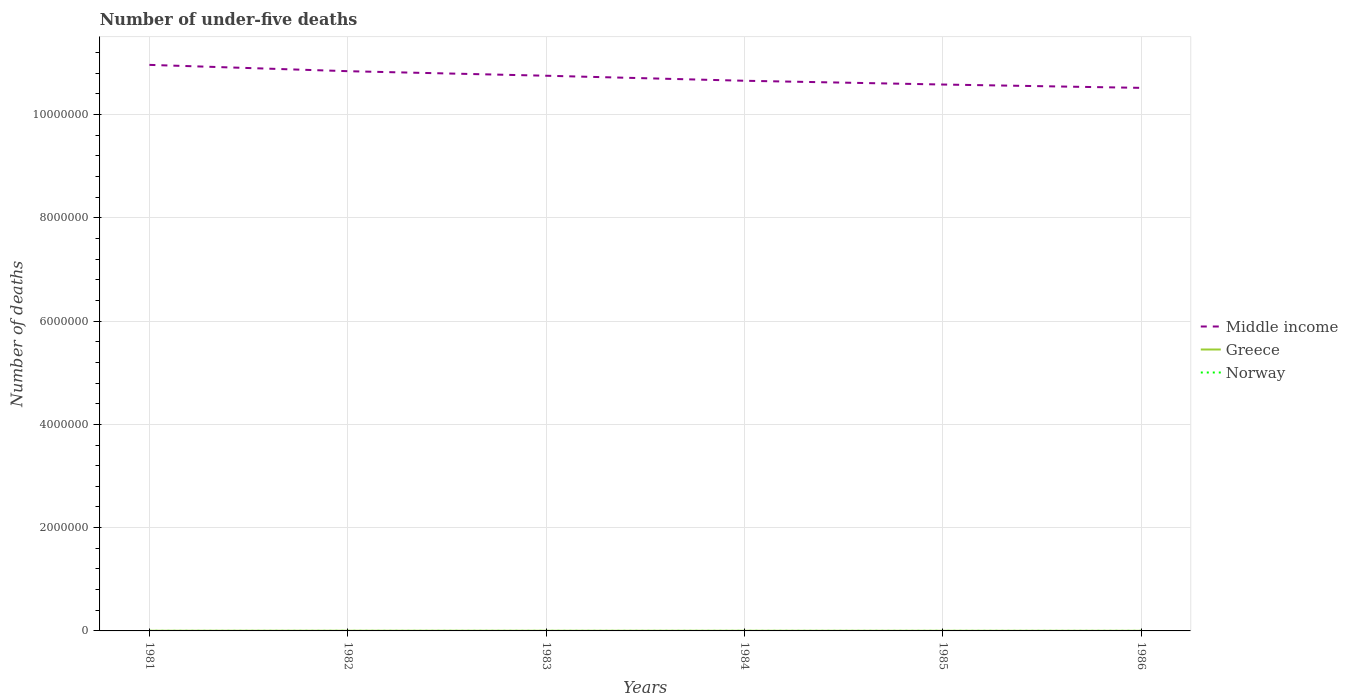How many different coloured lines are there?
Make the answer very short. 3. Across all years, what is the maximum number of under-five deaths in Greece?
Your answer should be compact. 2088. What is the total number of under-five deaths in Norway in the graph?
Your response must be concise. -61. What is the difference between the highest and the second highest number of under-five deaths in Norway?
Your response must be concise. 88. How many lines are there?
Provide a succinct answer. 3. What is the difference between two consecutive major ticks on the Y-axis?
Your answer should be compact. 2.00e+06. Are the values on the major ticks of Y-axis written in scientific E-notation?
Provide a short and direct response. No. Does the graph contain grids?
Provide a short and direct response. Yes. Where does the legend appear in the graph?
Offer a very short reply. Center right. How many legend labels are there?
Keep it short and to the point. 3. How are the legend labels stacked?
Make the answer very short. Vertical. What is the title of the graph?
Offer a terse response. Number of under-five deaths. Does "Iran" appear as one of the legend labels in the graph?
Provide a short and direct response. No. What is the label or title of the Y-axis?
Ensure brevity in your answer.  Number of deaths. What is the Number of deaths in Middle income in 1981?
Offer a terse response. 1.10e+07. What is the Number of deaths of Greece in 1981?
Your response must be concise. 3447. What is the Number of deaths in Norway in 1981?
Provide a short and direct response. 481. What is the Number of deaths in Middle income in 1982?
Your answer should be very brief. 1.08e+07. What is the Number of deaths in Greece in 1982?
Ensure brevity in your answer.  3181. What is the Number of deaths of Norway in 1982?
Provide a short and direct response. 489. What is the Number of deaths of Middle income in 1983?
Make the answer very short. 1.08e+07. What is the Number of deaths in Greece in 1983?
Give a very brief answer. 2898. What is the Number of deaths in Norway in 1983?
Offer a terse response. 508. What is the Number of deaths in Middle income in 1984?
Offer a very short reply. 1.07e+07. What is the Number of deaths in Greece in 1984?
Keep it short and to the point. 2618. What is the Number of deaths in Norway in 1984?
Offer a terse response. 530. What is the Number of deaths of Middle income in 1985?
Give a very brief answer. 1.06e+07. What is the Number of deaths in Greece in 1985?
Your response must be concise. 2340. What is the Number of deaths in Norway in 1985?
Provide a succinct answer. 550. What is the Number of deaths in Middle income in 1986?
Your answer should be very brief. 1.05e+07. What is the Number of deaths in Greece in 1986?
Offer a terse response. 2088. What is the Number of deaths in Norway in 1986?
Make the answer very short. 569. Across all years, what is the maximum Number of deaths of Middle income?
Give a very brief answer. 1.10e+07. Across all years, what is the maximum Number of deaths of Greece?
Your response must be concise. 3447. Across all years, what is the maximum Number of deaths of Norway?
Your response must be concise. 569. Across all years, what is the minimum Number of deaths in Middle income?
Your answer should be very brief. 1.05e+07. Across all years, what is the minimum Number of deaths in Greece?
Give a very brief answer. 2088. Across all years, what is the minimum Number of deaths in Norway?
Your response must be concise. 481. What is the total Number of deaths in Middle income in the graph?
Your answer should be very brief. 6.43e+07. What is the total Number of deaths in Greece in the graph?
Your answer should be compact. 1.66e+04. What is the total Number of deaths in Norway in the graph?
Ensure brevity in your answer.  3127. What is the difference between the Number of deaths of Middle income in 1981 and that in 1982?
Provide a short and direct response. 1.22e+05. What is the difference between the Number of deaths of Greece in 1981 and that in 1982?
Your answer should be compact. 266. What is the difference between the Number of deaths of Norway in 1981 and that in 1982?
Make the answer very short. -8. What is the difference between the Number of deaths in Middle income in 1981 and that in 1983?
Make the answer very short. 2.10e+05. What is the difference between the Number of deaths of Greece in 1981 and that in 1983?
Keep it short and to the point. 549. What is the difference between the Number of deaths of Norway in 1981 and that in 1983?
Your response must be concise. -27. What is the difference between the Number of deaths of Middle income in 1981 and that in 1984?
Provide a succinct answer. 3.08e+05. What is the difference between the Number of deaths of Greece in 1981 and that in 1984?
Offer a terse response. 829. What is the difference between the Number of deaths of Norway in 1981 and that in 1984?
Offer a terse response. -49. What is the difference between the Number of deaths of Middle income in 1981 and that in 1985?
Provide a succinct answer. 3.81e+05. What is the difference between the Number of deaths in Greece in 1981 and that in 1985?
Offer a terse response. 1107. What is the difference between the Number of deaths of Norway in 1981 and that in 1985?
Provide a short and direct response. -69. What is the difference between the Number of deaths of Middle income in 1981 and that in 1986?
Your answer should be very brief. 4.45e+05. What is the difference between the Number of deaths of Greece in 1981 and that in 1986?
Provide a short and direct response. 1359. What is the difference between the Number of deaths in Norway in 1981 and that in 1986?
Offer a terse response. -88. What is the difference between the Number of deaths in Middle income in 1982 and that in 1983?
Keep it short and to the point. 8.81e+04. What is the difference between the Number of deaths of Greece in 1982 and that in 1983?
Ensure brevity in your answer.  283. What is the difference between the Number of deaths of Norway in 1982 and that in 1983?
Your response must be concise. -19. What is the difference between the Number of deaths of Middle income in 1982 and that in 1984?
Ensure brevity in your answer.  1.85e+05. What is the difference between the Number of deaths of Greece in 1982 and that in 1984?
Give a very brief answer. 563. What is the difference between the Number of deaths in Norway in 1982 and that in 1984?
Keep it short and to the point. -41. What is the difference between the Number of deaths in Middle income in 1982 and that in 1985?
Provide a short and direct response. 2.58e+05. What is the difference between the Number of deaths in Greece in 1982 and that in 1985?
Your answer should be compact. 841. What is the difference between the Number of deaths of Norway in 1982 and that in 1985?
Your response must be concise. -61. What is the difference between the Number of deaths of Middle income in 1982 and that in 1986?
Your answer should be compact. 3.23e+05. What is the difference between the Number of deaths of Greece in 1982 and that in 1986?
Provide a short and direct response. 1093. What is the difference between the Number of deaths in Norway in 1982 and that in 1986?
Offer a terse response. -80. What is the difference between the Number of deaths of Middle income in 1983 and that in 1984?
Your response must be concise. 9.72e+04. What is the difference between the Number of deaths in Greece in 1983 and that in 1984?
Offer a very short reply. 280. What is the difference between the Number of deaths in Middle income in 1983 and that in 1985?
Your answer should be very brief. 1.70e+05. What is the difference between the Number of deaths of Greece in 1983 and that in 1985?
Keep it short and to the point. 558. What is the difference between the Number of deaths of Norway in 1983 and that in 1985?
Provide a short and direct response. -42. What is the difference between the Number of deaths of Middle income in 1983 and that in 1986?
Your answer should be very brief. 2.35e+05. What is the difference between the Number of deaths of Greece in 1983 and that in 1986?
Keep it short and to the point. 810. What is the difference between the Number of deaths in Norway in 1983 and that in 1986?
Offer a very short reply. -61. What is the difference between the Number of deaths in Middle income in 1984 and that in 1985?
Give a very brief answer. 7.30e+04. What is the difference between the Number of deaths in Greece in 1984 and that in 1985?
Make the answer very short. 278. What is the difference between the Number of deaths of Norway in 1984 and that in 1985?
Provide a succinct answer. -20. What is the difference between the Number of deaths of Middle income in 1984 and that in 1986?
Provide a short and direct response. 1.38e+05. What is the difference between the Number of deaths in Greece in 1984 and that in 1986?
Your answer should be very brief. 530. What is the difference between the Number of deaths in Norway in 1984 and that in 1986?
Keep it short and to the point. -39. What is the difference between the Number of deaths in Middle income in 1985 and that in 1986?
Ensure brevity in your answer.  6.48e+04. What is the difference between the Number of deaths in Greece in 1985 and that in 1986?
Make the answer very short. 252. What is the difference between the Number of deaths of Middle income in 1981 and the Number of deaths of Greece in 1982?
Keep it short and to the point. 1.10e+07. What is the difference between the Number of deaths in Middle income in 1981 and the Number of deaths in Norway in 1982?
Provide a succinct answer. 1.10e+07. What is the difference between the Number of deaths in Greece in 1981 and the Number of deaths in Norway in 1982?
Your answer should be compact. 2958. What is the difference between the Number of deaths in Middle income in 1981 and the Number of deaths in Greece in 1983?
Your answer should be compact. 1.10e+07. What is the difference between the Number of deaths of Middle income in 1981 and the Number of deaths of Norway in 1983?
Offer a terse response. 1.10e+07. What is the difference between the Number of deaths in Greece in 1981 and the Number of deaths in Norway in 1983?
Provide a succinct answer. 2939. What is the difference between the Number of deaths in Middle income in 1981 and the Number of deaths in Greece in 1984?
Provide a succinct answer. 1.10e+07. What is the difference between the Number of deaths in Middle income in 1981 and the Number of deaths in Norway in 1984?
Ensure brevity in your answer.  1.10e+07. What is the difference between the Number of deaths of Greece in 1981 and the Number of deaths of Norway in 1984?
Offer a terse response. 2917. What is the difference between the Number of deaths in Middle income in 1981 and the Number of deaths in Greece in 1985?
Give a very brief answer. 1.10e+07. What is the difference between the Number of deaths of Middle income in 1981 and the Number of deaths of Norway in 1985?
Your answer should be very brief. 1.10e+07. What is the difference between the Number of deaths in Greece in 1981 and the Number of deaths in Norway in 1985?
Give a very brief answer. 2897. What is the difference between the Number of deaths of Middle income in 1981 and the Number of deaths of Greece in 1986?
Your response must be concise. 1.10e+07. What is the difference between the Number of deaths in Middle income in 1981 and the Number of deaths in Norway in 1986?
Provide a short and direct response. 1.10e+07. What is the difference between the Number of deaths of Greece in 1981 and the Number of deaths of Norway in 1986?
Give a very brief answer. 2878. What is the difference between the Number of deaths in Middle income in 1982 and the Number of deaths in Greece in 1983?
Provide a short and direct response. 1.08e+07. What is the difference between the Number of deaths of Middle income in 1982 and the Number of deaths of Norway in 1983?
Offer a very short reply. 1.08e+07. What is the difference between the Number of deaths in Greece in 1982 and the Number of deaths in Norway in 1983?
Make the answer very short. 2673. What is the difference between the Number of deaths of Middle income in 1982 and the Number of deaths of Greece in 1984?
Your answer should be very brief. 1.08e+07. What is the difference between the Number of deaths in Middle income in 1982 and the Number of deaths in Norway in 1984?
Offer a terse response. 1.08e+07. What is the difference between the Number of deaths of Greece in 1982 and the Number of deaths of Norway in 1984?
Give a very brief answer. 2651. What is the difference between the Number of deaths of Middle income in 1982 and the Number of deaths of Greece in 1985?
Your response must be concise. 1.08e+07. What is the difference between the Number of deaths in Middle income in 1982 and the Number of deaths in Norway in 1985?
Keep it short and to the point. 1.08e+07. What is the difference between the Number of deaths of Greece in 1982 and the Number of deaths of Norway in 1985?
Ensure brevity in your answer.  2631. What is the difference between the Number of deaths in Middle income in 1982 and the Number of deaths in Greece in 1986?
Ensure brevity in your answer.  1.08e+07. What is the difference between the Number of deaths in Middle income in 1982 and the Number of deaths in Norway in 1986?
Your response must be concise. 1.08e+07. What is the difference between the Number of deaths of Greece in 1982 and the Number of deaths of Norway in 1986?
Your response must be concise. 2612. What is the difference between the Number of deaths in Middle income in 1983 and the Number of deaths in Greece in 1984?
Your answer should be compact. 1.07e+07. What is the difference between the Number of deaths in Middle income in 1983 and the Number of deaths in Norway in 1984?
Keep it short and to the point. 1.08e+07. What is the difference between the Number of deaths in Greece in 1983 and the Number of deaths in Norway in 1984?
Offer a very short reply. 2368. What is the difference between the Number of deaths of Middle income in 1983 and the Number of deaths of Greece in 1985?
Your response must be concise. 1.07e+07. What is the difference between the Number of deaths in Middle income in 1983 and the Number of deaths in Norway in 1985?
Ensure brevity in your answer.  1.08e+07. What is the difference between the Number of deaths in Greece in 1983 and the Number of deaths in Norway in 1985?
Your answer should be compact. 2348. What is the difference between the Number of deaths of Middle income in 1983 and the Number of deaths of Greece in 1986?
Offer a very short reply. 1.07e+07. What is the difference between the Number of deaths in Middle income in 1983 and the Number of deaths in Norway in 1986?
Your answer should be compact. 1.08e+07. What is the difference between the Number of deaths of Greece in 1983 and the Number of deaths of Norway in 1986?
Ensure brevity in your answer.  2329. What is the difference between the Number of deaths of Middle income in 1984 and the Number of deaths of Greece in 1985?
Give a very brief answer. 1.07e+07. What is the difference between the Number of deaths in Middle income in 1984 and the Number of deaths in Norway in 1985?
Offer a terse response. 1.07e+07. What is the difference between the Number of deaths in Greece in 1984 and the Number of deaths in Norway in 1985?
Provide a succinct answer. 2068. What is the difference between the Number of deaths of Middle income in 1984 and the Number of deaths of Greece in 1986?
Keep it short and to the point. 1.07e+07. What is the difference between the Number of deaths in Middle income in 1984 and the Number of deaths in Norway in 1986?
Make the answer very short. 1.07e+07. What is the difference between the Number of deaths of Greece in 1984 and the Number of deaths of Norway in 1986?
Your response must be concise. 2049. What is the difference between the Number of deaths in Middle income in 1985 and the Number of deaths in Greece in 1986?
Offer a terse response. 1.06e+07. What is the difference between the Number of deaths in Middle income in 1985 and the Number of deaths in Norway in 1986?
Provide a succinct answer. 1.06e+07. What is the difference between the Number of deaths in Greece in 1985 and the Number of deaths in Norway in 1986?
Provide a succinct answer. 1771. What is the average Number of deaths of Middle income per year?
Your response must be concise. 1.07e+07. What is the average Number of deaths in Greece per year?
Offer a terse response. 2762. What is the average Number of deaths in Norway per year?
Give a very brief answer. 521.17. In the year 1981, what is the difference between the Number of deaths in Middle income and Number of deaths in Greece?
Provide a short and direct response. 1.10e+07. In the year 1981, what is the difference between the Number of deaths of Middle income and Number of deaths of Norway?
Provide a succinct answer. 1.10e+07. In the year 1981, what is the difference between the Number of deaths in Greece and Number of deaths in Norway?
Your response must be concise. 2966. In the year 1982, what is the difference between the Number of deaths in Middle income and Number of deaths in Greece?
Your answer should be compact. 1.08e+07. In the year 1982, what is the difference between the Number of deaths of Middle income and Number of deaths of Norway?
Your answer should be compact. 1.08e+07. In the year 1982, what is the difference between the Number of deaths of Greece and Number of deaths of Norway?
Provide a succinct answer. 2692. In the year 1983, what is the difference between the Number of deaths in Middle income and Number of deaths in Greece?
Your response must be concise. 1.07e+07. In the year 1983, what is the difference between the Number of deaths in Middle income and Number of deaths in Norway?
Give a very brief answer. 1.08e+07. In the year 1983, what is the difference between the Number of deaths of Greece and Number of deaths of Norway?
Your answer should be very brief. 2390. In the year 1984, what is the difference between the Number of deaths in Middle income and Number of deaths in Greece?
Offer a terse response. 1.07e+07. In the year 1984, what is the difference between the Number of deaths in Middle income and Number of deaths in Norway?
Offer a very short reply. 1.07e+07. In the year 1984, what is the difference between the Number of deaths in Greece and Number of deaths in Norway?
Offer a terse response. 2088. In the year 1985, what is the difference between the Number of deaths of Middle income and Number of deaths of Greece?
Your answer should be compact. 1.06e+07. In the year 1985, what is the difference between the Number of deaths in Middle income and Number of deaths in Norway?
Offer a very short reply. 1.06e+07. In the year 1985, what is the difference between the Number of deaths in Greece and Number of deaths in Norway?
Offer a very short reply. 1790. In the year 1986, what is the difference between the Number of deaths in Middle income and Number of deaths in Greece?
Offer a terse response. 1.05e+07. In the year 1986, what is the difference between the Number of deaths of Middle income and Number of deaths of Norway?
Offer a very short reply. 1.05e+07. In the year 1986, what is the difference between the Number of deaths of Greece and Number of deaths of Norway?
Provide a succinct answer. 1519. What is the ratio of the Number of deaths of Middle income in 1981 to that in 1982?
Keep it short and to the point. 1.01. What is the ratio of the Number of deaths in Greece in 1981 to that in 1982?
Your response must be concise. 1.08. What is the ratio of the Number of deaths of Norway in 1981 to that in 1982?
Make the answer very short. 0.98. What is the ratio of the Number of deaths in Middle income in 1981 to that in 1983?
Provide a succinct answer. 1.02. What is the ratio of the Number of deaths of Greece in 1981 to that in 1983?
Make the answer very short. 1.19. What is the ratio of the Number of deaths in Norway in 1981 to that in 1983?
Give a very brief answer. 0.95. What is the ratio of the Number of deaths of Middle income in 1981 to that in 1984?
Offer a very short reply. 1.03. What is the ratio of the Number of deaths of Greece in 1981 to that in 1984?
Your answer should be compact. 1.32. What is the ratio of the Number of deaths of Norway in 1981 to that in 1984?
Offer a very short reply. 0.91. What is the ratio of the Number of deaths of Middle income in 1981 to that in 1985?
Your response must be concise. 1.04. What is the ratio of the Number of deaths in Greece in 1981 to that in 1985?
Your answer should be compact. 1.47. What is the ratio of the Number of deaths of Norway in 1981 to that in 1985?
Offer a terse response. 0.87. What is the ratio of the Number of deaths of Middle income in 1981 to that in 1986?
Give a very brief answer. 1.04. What is the ratio of the Number of deaths in Greece in 1981 to that in 1986?
Your answer should be compact. 1.65. What is the ratio of the Number of deaths of Norway in 1981 to that in 1986?
Make the answer very short. 0.85. What is the ratio of the Number of deaths in Middle income in 1982 to that in 1983?
Your response must be concise. 1.01. What is the ratio of the Number of deaths in Greece in 1982 to that in 1983?
Give a very brief answer. 1.1. What is the ratio of the Number of deaths of Norway in 1982 to that in 1983?
Your response must be concise. 0.96. What is the ratio of the Number of deaths of Middle income in 1982 to that in 1984?
Your answer should be very brief. 1.02. What is the ratio of the Number of deaths in Greece in 1982 to that in 1984?
Keep it short and to the point. 1.22. What is the ratio of the Number of deaths in Norway in 1982 to that in 1984?
Offer a very short reply. 0.92. What is the ratio of the Number of deaths in Middle income in 1982 to that in 1985?
Make the answer very short. 1.02. What is the ratio of the Number of deaths in Greece in 1982 to that in 1985?
Your answer should be very brief. 1.36. What is the ratio of the Number of deaths in Norway in 1982 to that in 1985?
Your answer should be compact. 0.89. What is the ratio of the Number of deaths of Middle income in 1982 to that in 1986?
Provide a succinct answer. 1.03. What is the ratio of the Number of deaths of Greece in 1982 to that in 1986?
Provide a short and direct response. 1.52. What is the ratio of the Number of deaths of Norway in 1982 to that in 1986?
Your answer should be compact. 0.86. What is the ratio of the Number of deaths in Middle income in 1983 to that in 1984?
Your response must be concise. 1.01. What is the ratio of the Number of deaths of Greece in 1983 to that in 1984?
Your answer should be compact. 1.11. What is the ratio of the Number of deaths of Norway in 1983 to that in 1984?
Your answer should be compact. 0.96. What is the ratio of the Number of deaths in Middle income in 1983 to that in 1985?
Your answer should be compact. 1.02. What is the ratio of the Number of deaths of Greece in 1983 to that in 1985?
Keep it short and to the point. 1.24. What is the ratio of the Number of deaths in Norway in 1983 to that in 1985?
Make the answer very short. 0.92. What is the ratio of the Number of deaths in Middle income in 1983 to that in 1986?
Keep it short and to the point. 1.02. What is the ratio of the Number of deaths of Greece in 1983 to that in 1986?
Your answer should be compact. 1.39. What is the ratio of the Number of deaths of Norway in 1983 to that in 1986?
Keep it short and to the point. 0.89. What is the ratio of the Number of deaths of Middle income in 1984 to that in 1985?
Keep it short and to the point. 1.01. What is the ratio of the Number of deaths of Greece in 1984 to that in 1985?
Ensure brevity in your answer.  1.12. What is the ratio of the Number of deaths in Norway in 1984 to that in 1985?
Offer a terse response. 0.96. What is the ratio of the Number of deaths of Middle income in 1984 to that in 1986?
Keep it short and to the point. 1.01. What is the ratio of the Number of deaths in Greece in 1984 to that in 1986?
Offer a very short reply. 1.25. What is the ratio of the Number of deaths of Norway in 1984 to that in 1986?
Give a very brief answer. 0.93. What is the ratio of the Number of deaths in Greece in 1985 to that in 1986?
Make the answer very short. 1.12. What is the ratio of the Number of deaths of Norway in 1985 to that in 1986?
Provide a succinct answer. 0.97. What is the difference between the highest and the second highest Number of deaths in Middle income?
Offer a very short reply. 1.22e+05. What is the difference between the highest and the second highest Number of deaths in Greece?
Your answer should be very brief. 266. What is the difference between the highest and the second highest Number of deaths of Norway?
Your response must be concise. 19. What is the difference between the highest and the lowest Number of deaths in Middle income?
Make the answer very short. 4.45e+05. What is the difference between the highest and the lowest Number of deaths of Greece?
Your response must be concise. 1359. 